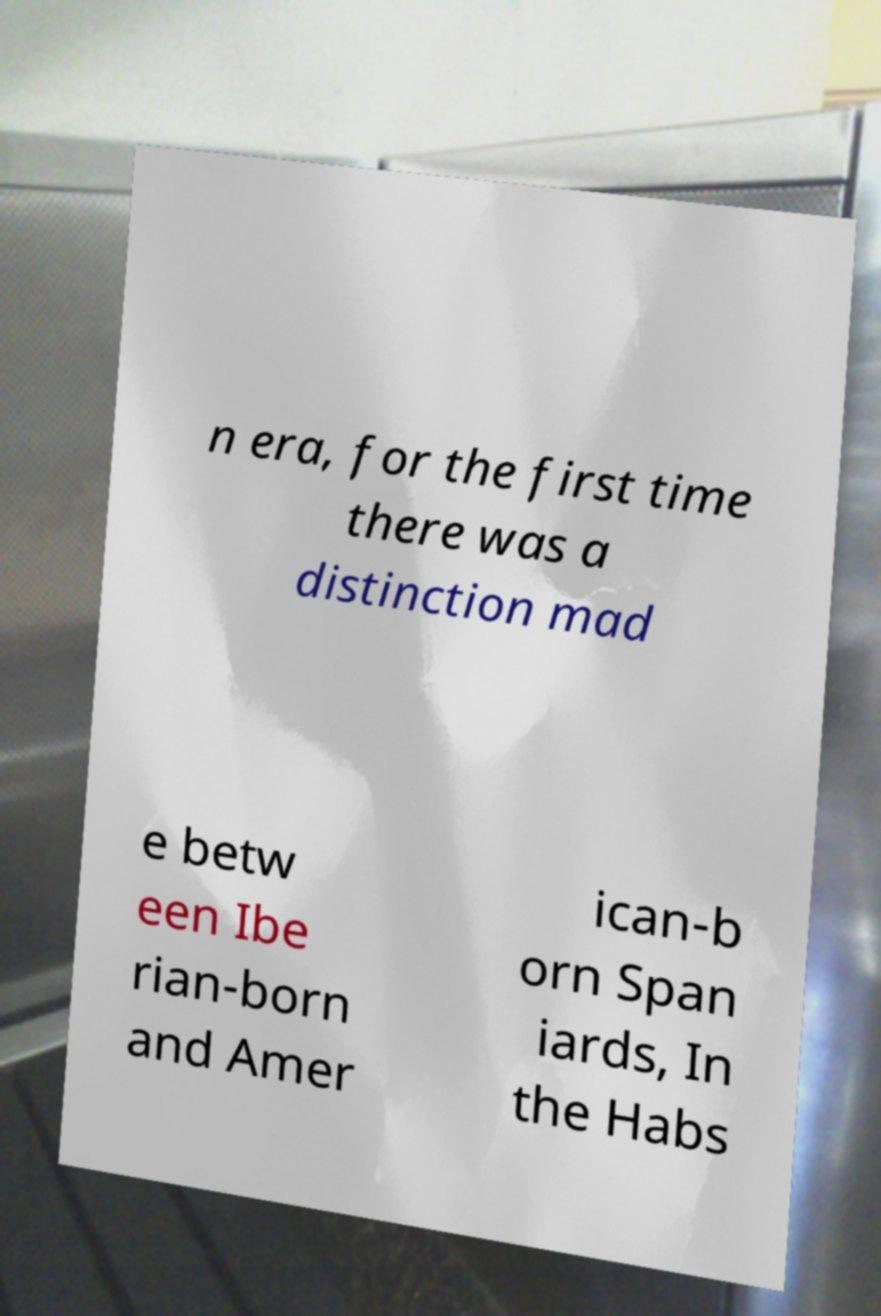Can you read and provide the text displayed in the image?This photo seems to have some interesting text. Can you extract and type it out for me? n era, for the first time there was a distinction mad e betw een Ibe rian-born and Amer ican-b orn Span iards, In the Habs 